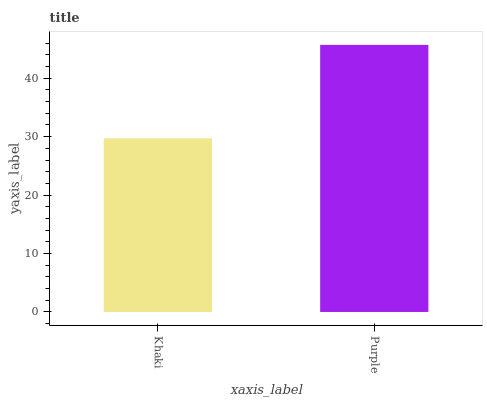Is Khaki the minimum?
Answer yes or no. Yes. Is Purple the maximum?
Answer yes or no. Yes. Is Purple the minimum?
Answer yes or no. No. Is Purple greater than Khaki?
Answer yes or no. Yes. Is Khaki less than Purple?
Answer yes or no. Yes. Is Khaki greater than Purple?
Answer yes or no. No. Is Purple less than Khaki?
Answer yes or no. No. Is Purple the high median?
Answer yes or no. Yes. Is Khaki the low median?
Answer yes or no. Yes. Is Khaki the high median?
Answer yes or no. No. Is Purple the low median?
Answer yes or no. No. 